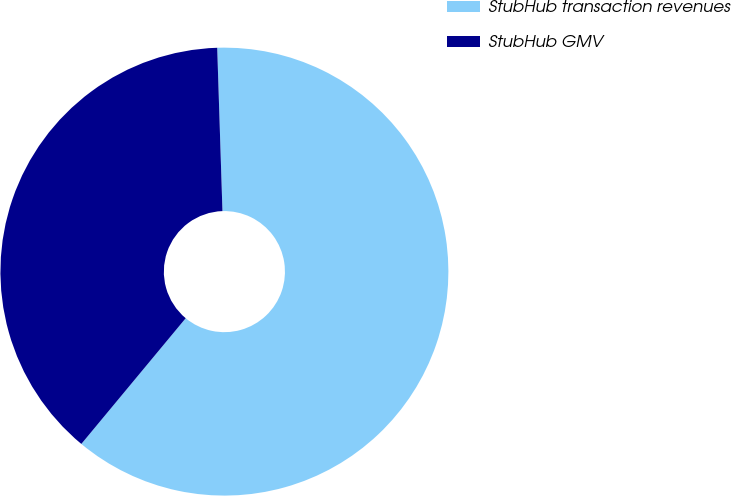Convert chart. <chart><loc_0><loc_0><loc_500><loc_500><pie_chart><fcel>StubHub transaction revenues<fcel>StubHub GMV<nl><fcel>61.54%<fcel>38.46%<nl></chart> 